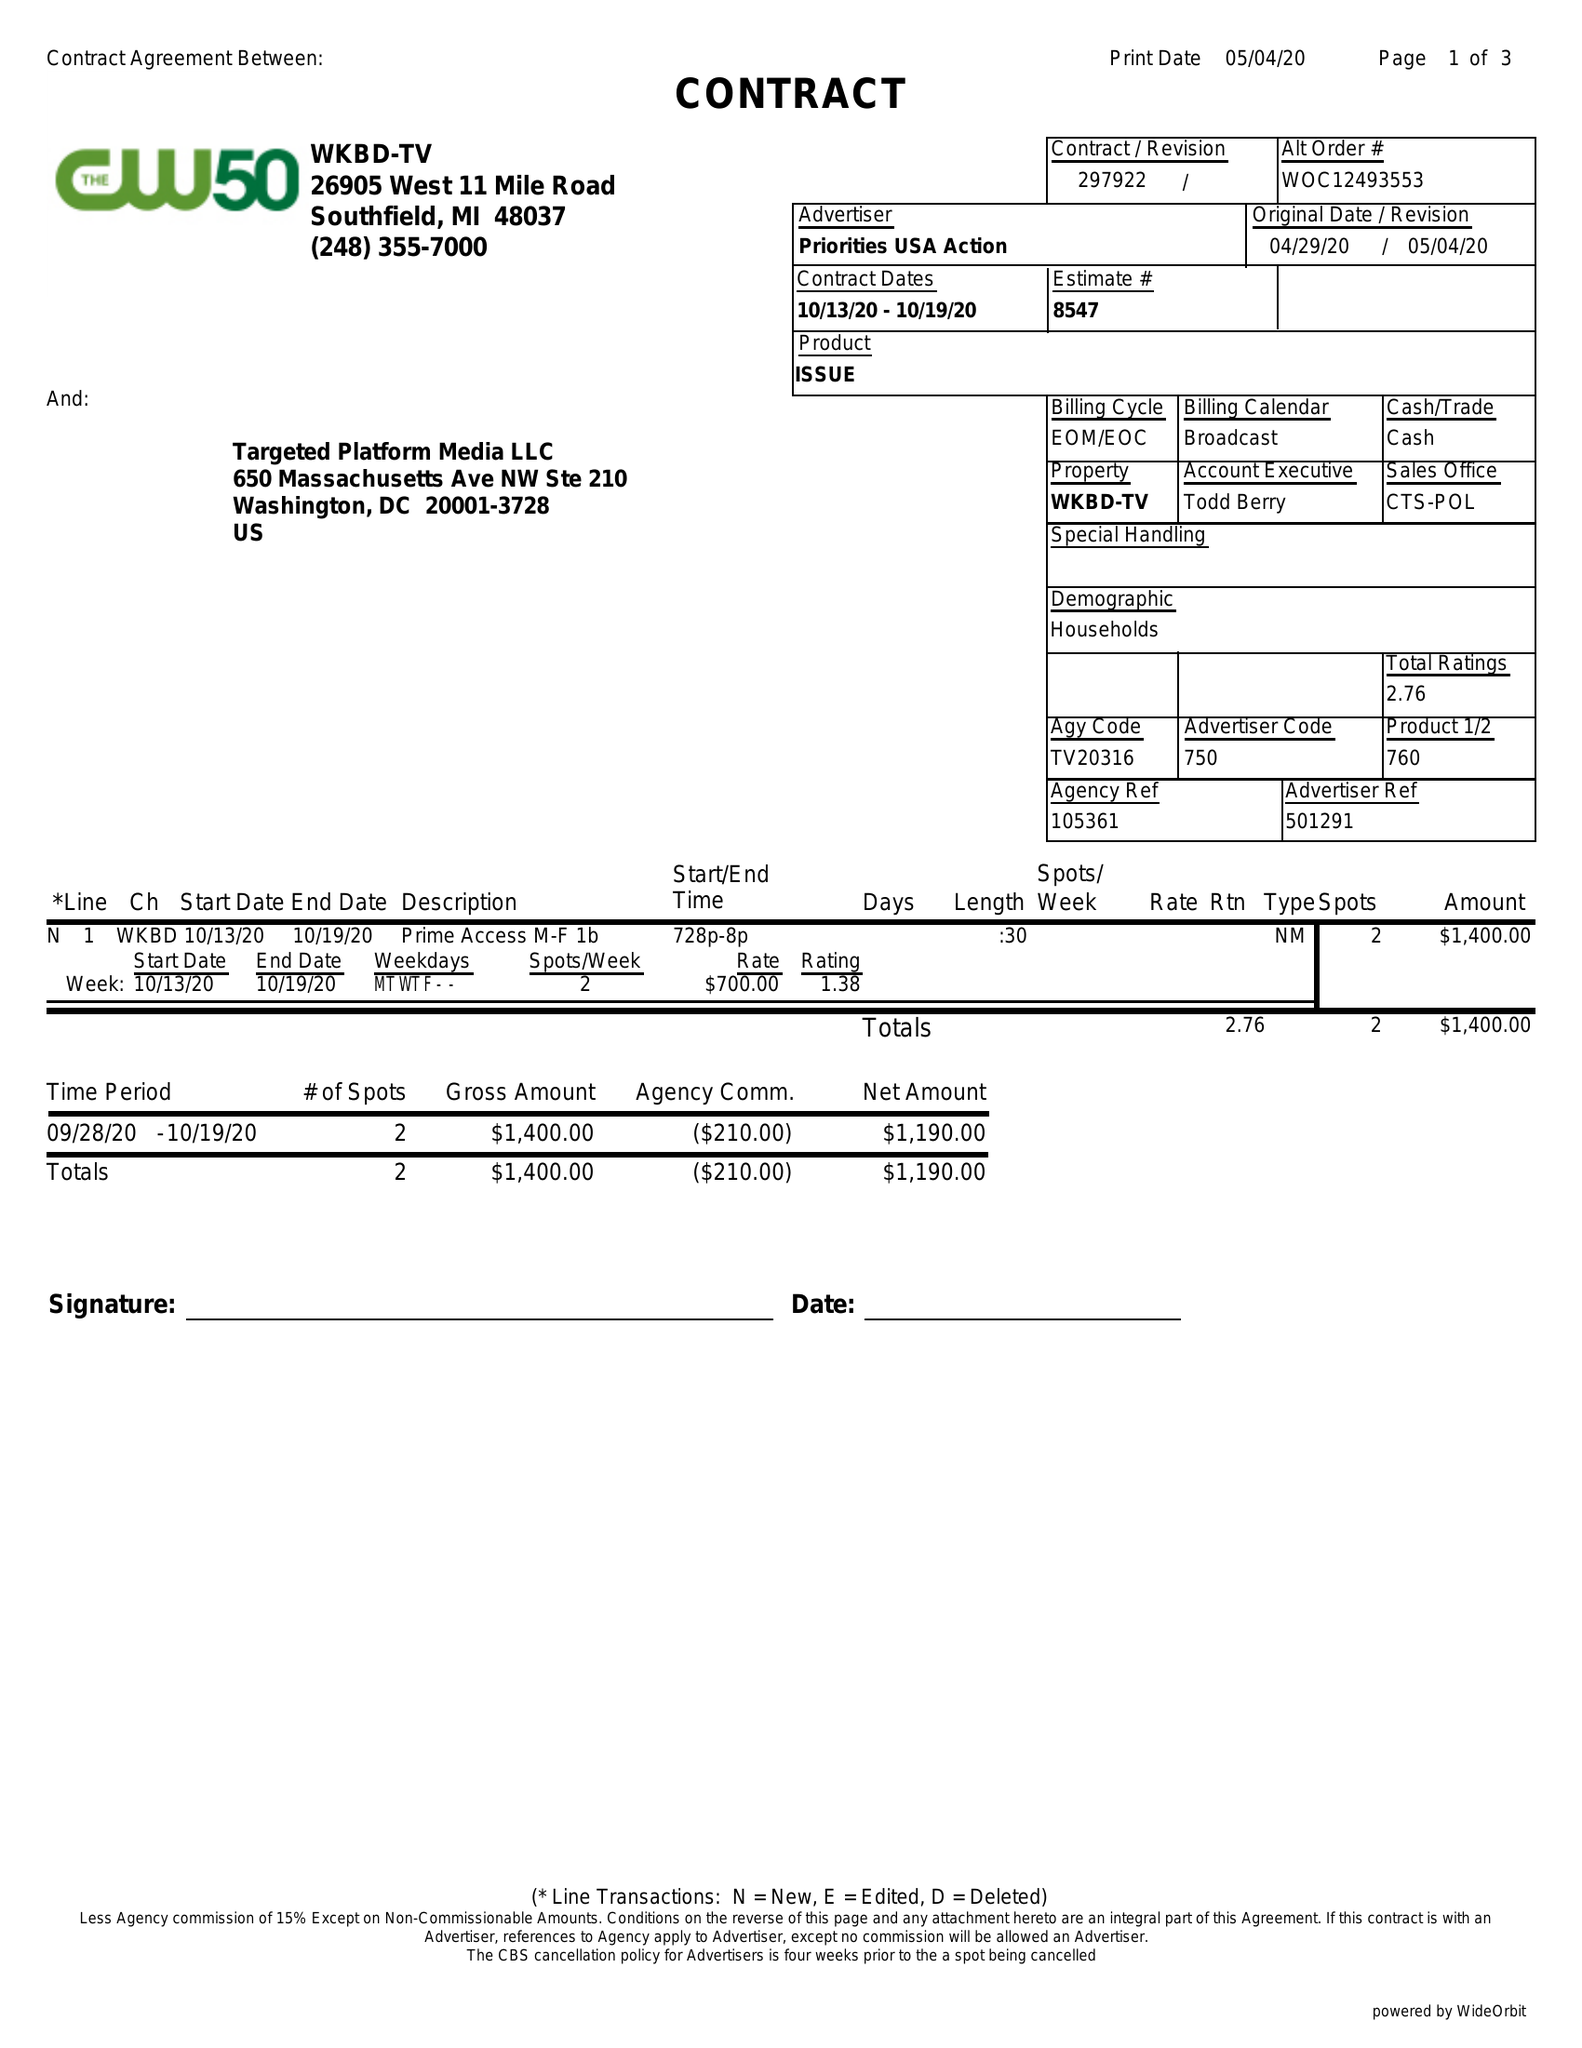What is the value for the flight_from?
Answer the question using a single word or phrase. 10/13/20 